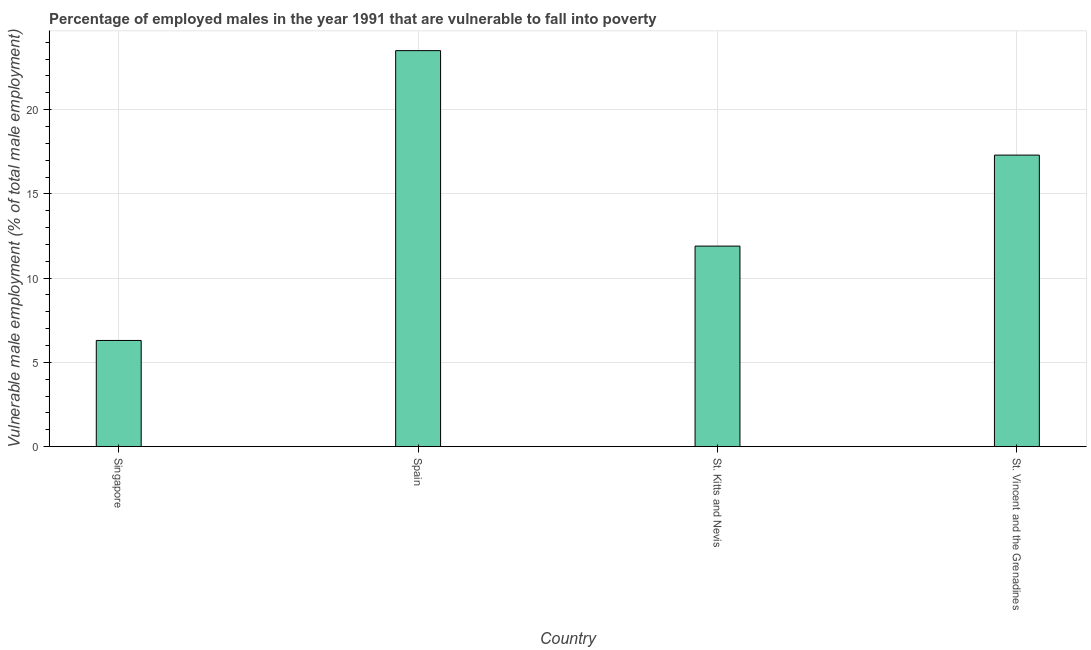Does the graph contain any zero values?
Keep it short and to the point. No. Does the graph contain grids?
Your answer should be very brief. Yes. What is the title of the graph?
Offer a very short reply. Percentage of employed males in the year 1991 that are vulnerable to fall into poverty. What is the label or title of the X-axis?
Your answer should be compact. Country. What is the label or title of the Y-axis?
Ensure brevity in your answer.  Vulnerable male employment (% of total male employment). Across all countries, what is the minimum percentage of employed males who are vulnerable to fall into poverty?
Provide a succinct answer. 6.3. In which country was the percentage of employed males who are vulnerable to fall into poverty maximum?
Make the answer very short. Spain. In which country was the percentage of employed males who are vulnerable to fall into poverty minimum?
Ensure brevity in your answer.  Singapore. What is the sum of the percentage of employed males who are vulnerable to fall into poverty?
Keep it short and to the point. 59. What is the average percentage of employed males who are vulnerable to fall into poverty per country?
Offer a very short reply. 14.75. What is the median percentage of employed males who are vulnerable to fall into poverty?
Provide a short and direct response. 14.6. What is the ratio of the percentage of employed males who are vulnerable to fall into poverty in Singapore to that in St. Kitts and Nevis?
Keep it short and to the point. 0.53. Is the percentage of employed males who are vulnerable to fall into poverty in Singapore less than that in St. Kitts and Nevis?
Ensure brevity in your answer.  Yes. Is the sum of the percentage of employed males who are vulnerable to fall into poverty in Singapore and Spain greater than the maximum percentage of employed males who are vulnerable to fall into poverty across all countries?
Provide a succinct answer. Yes. What is the difference between the highest and the lowest percentage of employed males who are vulnerable to fall into poverty?
Your answer should be compact. 17.2. How many bars are there?
Your response must be concise. 4. How many countries are there in the graph?
Provide a short and direct response. 4. What is the Vulnerable male employment (% of total male employment) in Singapore?
Offer a terse response. 6.3. What is the Vulnerable male employment (% of total male employment) in Spain?
Your answer should be very brief. 23.5. What is the Vulnerable male employment (% of total male employment) in St. Kitts and Nevis?
Your response must be concise. 11.9. What is the Vulnerable male employment (% of total male employment) of St. Vincent and the Grenadines?
Offer a very short reply. 17.3. What is the difference between the Vulnerable male employment (% of total male employment) in Singapore and Spain?
Ensure brevity in your answer.  -17.2. What is the difference between the Vulnerable male employment (% of total male employment) in Singapore and St. Kitts and Nevis?
Provide a short and direct response. -5.6. What is the difference between the Vulnerable male employment (% of total male employment) in Spain and St. Kitts and Nevis?
Ensure brevity in your answer.  11.6. What is the difference between the Vulnerable male employment (% of total male employment) in St. Kitts and Nevis and St. Vincent and the Grenadines?
Your response must be concise. -5.4. What is the ratio of the Vulnerable male employment (% of total male employment) in Singapore to that in Spain?
Provide a succinct answer. 0.27. What is the ratio of the Vulnerable male employment (% of total male employment) in Singapore to that in St. Kitts and Nevis?
Offer a terse response. 0.53. What is the ratio of the Vulnerable male employment (% of total male employment) in Singapore to that in St. Vincent and the Grenadines?
Offer a terse response. 0.36. What is the ratio of the Vulnerable male employment (% of total male employment) in Spain to that in St. Kitts and Nevis?
Provide a succinct answer. 1.98. What is the ratio of the Vulnerable male employment (% of total male employment) in Spain to that in St. Vincent and the Grenadines?
Offer a very short reply. 1.36. What is the ratio of the Vulnerable male employment (% of total male employment) in St. Kitts and Nevis to that in St. Vincent and the Grenadines?
Offer a terse response. 0.69. 